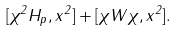Convert formula to latex. <formula><loc_0><loc_0><loc_500><loc_500>[ \chi ^ { 2 } H _ { p } , x ^ { 2 } ] + [ \chi W \chi , x ^ { 2 } ] .</formula> 